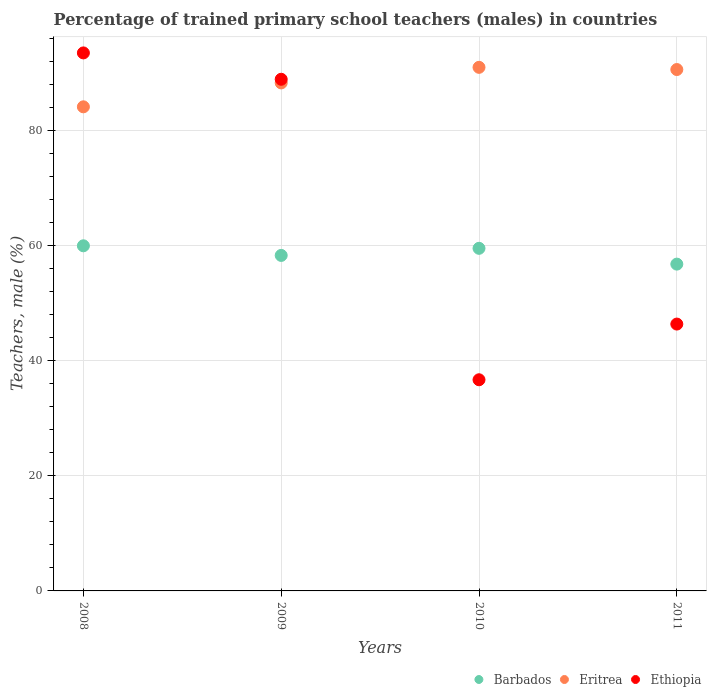How many different coloured dotlines are there?
Your answer should be compact. 3. What is the percentage of trained primary school teachers (males) in Ethiopia in 2008?
Offer a very short reply. 93.51. Across all years, what is the maximum percentage of trained primary school teachers (males) in Ethiopia?
Provide a succinct answer. 93.51. Across all years, what is the minimum percentage of trained primary school teachers (males) in Eritrea?
Your answer should be compact. 84.14. In which year was the percentage of trained primary school teachers (males) in Eritrea maximum?
Your answer should be very brief. 2010. In which year was the percentage of trained primary school teachers (males) in Eritrea minimum?
Provide a succinct answer. 2008. What is the total percentage of trained primary school teachers (males) in Barbados in the graph?
Ensure brevity in your answer.  234.65. What is the difference between the percentage of trained primary school teachers (males) in Ethiopia in 2010 and that in 2011?
Provide a short and direct response. -9.68. What is the difference between the percentage of trained primary school teachers (males) in Eritrea in 2008 and the percentage of trained primary school teachers (males) in Ethiopia in 2010?
Keep it short and to the point. 47.44. What is the average percentage of trained primary school teachers (males) in Eritrea per year?
Ensure brevity in your answer.  88.52. In the year 2010, what is the difference between the percentage of trained primary school teachers (males) in Barbados and percentage of trained primary school teachers (males) in Eritrea?
Provide a short and direct response. -31.46. What is the ratio of the percentage of trained primary school teachers (males) in Barbados in 2008 to that in 2009?
Your response must be concise. 1.03. Is the percentage of trained primary school teachers (males) in Ethiopia in 2008 less than that in 2009?
Your answer should be compact. No. What is the difference between the highest and the second highest percentage of trained primary school teachers (males) in Barbados?
Your answer should be very brief. 0.44. What is the difference between the highest and the lowest percentage of trained primary school teachers (males) in Eritrea?
Offer a terse response. 6.86. In how many years, is the percentage of trained primary school teachers (males) in Ethiopia greater than the average percentage of trained primary school teachers (males) in Ethiopia taken over all years?
Offer a very short reply. 2. Is it the case that in every year, the sum of the percentage of trained primary school teachers (males) in Eritrea and percentage of trained primary school teachers (males) in Ethiopia  is greater than the percentage of trained primary school teachers (males) in Barbados?
Your answer should be very brief. Yes. Is the percentage of trained primary school teachers (males) in Eritrea strictly greater than the percentage of trained primary school teachers (males) in Barbados over the years?
Ensure brevity in your answer.  Yes. How many dotlines are there?
Make the answer very short. 3. Are the values on the major ticks of Y-axis written in scientific E-notation?
Provide a short and direct response. No. Does the graph contain any zero values?
Give a very brief answer. No. How many legend labels are there?
Offer a very short reply. 3. How are the legend labels stacked?
Your answer should be very brief. Horizontal. What is the title of the graph?
Give a very brief answer. Percentage of trained primary school teachers (males) in countries. What is the label or title of the X-axis?
Keep it short and to the point. Years. What is the label or title of the Y-axis?
Ensure brevity in your answer.  Teachers, male (%). What is the Teachers, male (%) in Barbados in 2008?
Your answer should be very brief. 59.99. What is the Teachers, male (%) of Eritrea in 2008?
Provide a short and direct response. 84.14. What is the Teachers, male (%) in Ethiopia in 2008?
Offer a very short reply. 93.51. What is the Teachers, male (%) in Barbados in 2009?
Ensure brevity in your answer.  58.31. What is the Teachers, male (%) in Eritrea in 2009?
Offer a very short reply. 88.3. What is the Teachers, male (%) in Ethiopia in 2009?
Your response must be concise. 88.93. What is the Teachers, male (%) in Barbados in 2010?
Offer a terse response. 59.55. What is the Teachers, male (%) of Eritrea in 2010?
Your answer should be compact. 91. What is the Teachers, male (%) in Ethiopia in 2010?
Your response must be concise. 36.7. What is the Teachers, male (%) of Barbados in 2011?
Keep it short and to the point. 56.8. What is the Teachers, male (%) in Eritrea in 2011?
Your answer should be very brief. 90.62. What is the Teachers, male (%) of Ethiopia in 2011?
Keep it short and to the point. 46.38. Across all years, what is the maximum Teachers, male (%) of Barbados?
Provide a short and direct response. 59.99. Across all years, what is the maximum Teachers, male (%) in Eritrea?
Offer a very short reply. 91. Across all years, what is the maximum Teachers, male (%) of Ethiopia?
Give a very brief answer. 93.51. Across all years, what is the minimum Teachers, male (%) of Barbados?
Your response must be concise. 56.8. Across all years, what is the minimum Teachers, male (%) of Eritrea?
Offer a very short reply. 84.14. Across all years, what is the minimum Teachers, male (%) in Ethiopia?
Keep it short and to the point. 36.7. What is the total Teachers, male (%) in Barbados in the graph?
Your answer should be very brief. 234.65. What is the total Teachers, male (%) in Eritrea in the graph?
Offer a very short reply. 354.06. What is the total Teachers, male (%) of Ethiopia in the graph?
Ensure brevity in your answer.  265.52. What is the difference between the Teachers, male (%) in Barbados in 2008 and that in 2009?
Offer a very short reply. 1.67. What is the difference between the Teachers, male (%) in Eritrea in 2008 and that in 2009?
Offer a terse response. -4.15. What is the difference between the Teachers, male (%) in Ethiopia in 2008 and that in 2009?
Provide a short and direct response. 4.58. What is the difference between the Teachers, male (%) of Barbados in 2008 and that in 2010?
Keep it short and to the point. 0.44. What is the difference between the Teachers, male (%) of Eritrea in 2008 and that in 2010?
Provide a short and direct response. -6.86. What is the difference between the Teachers, male (%) of Ethiopia in 2008 and that in 2010?
Your answer should be very brief. 56.81. What is the difference between the Teachers, male (%) of Barbados in 2008 and that in 2011?
Make the answer very short. 3.18. What is the difference between the Teachers, male (%) of Eritrea in 2008 and that in 2011?
Your response must be concise. -6.48. What is the difference between the Teachers, male (%) in Ethiopia in 2008 and that in 2011?
Provide a succinct answer. 47.13. What is the difference between the Teachers, male (%) of Barbados in 2009 and that in 2010?
Offer a terse response. -1.23. What is the difference between the Teachers, male (%) of Eritrea in 2009 and that in 2010?
Keep it short and to the point. -2.71. What is the difference between the Teachers, male (%) of Ethiopia in 2009 and that in 2010?
Your answer should be very brief. 52.23. What is the difference between the Teachers, male (%) in Barbados in 2009 and that in 2011?
Offer a very short reply. 1.51. What is the difference between the Teachers, male (%) in Eritrea in 2009 and that in 2011?
Keep it short and to the point. -2.33. What is the difference between the Teachers, male (%) of Ethiopia in 2009 and that in 2011?
Offer a terse response. 42.55. What is the difference between the Teachers, male (%) in Barbados in 2010 and that in 2011?
Your answer should be very brief. 2.75. What is the difference between the Teachers, male (%) in Eritrea in 2010 and that in 2011?
Offer a terse response. 0.38. What is the difference between the Teachers, male (%) in Ethiopia in 2010 and that in 2011?
Make the answer very short. -9.68. What is the difference between the Teachers, male (%) in Barbados in 2008 and the Teachers, male (%) in Eritrea in 2009?
Your response must be concise. -28.31. What is the difference between the Teachers, male (%) of Barbados in 2008 and the Teachers, male (%) of Ethiopia in 2009?
Your answer should be compact. -28.94. What is the difference between the Teachers, male (%) of Eritrea in 2008 and the Teachers, male (%) of Ethiopia in 2009?
Offer a terse response. -4.79. What is the difference between the Teachers, male (%) in Barbados in 2008 and the Teachers, male (%) in Eritrea in 2010?
Provide a short and direct response. -31.02. What is the difference between the Teachers, male (%) in Barbados in 2008 and the Teachers, male (%) in Ethiopia in 2010?
Offer a terse response. 23.28. What is the difference between the Teachers, male (%) of Eritrea in 2008 and the Teachers, male (%) of Ethiopia in 2010?
Offer a terse response. 47.44. What is the difference between the Teachers, male (%) in Barbados in 2008 and the Teachers, male (%) in Eritrea in 2011?
Keep it short and to the point. -30.64. What is the difference between the Teachers, male (%) of Barbados in 2008 and the Teachers, male (%) of Ethiopia in 2011?
Provide a short and direct response. 13.6. What is the difference between the Teachers, male (%) of Eritrea in 2008 and the Teachers, male (%) of Ethiopia in 2011?
Ensure brevity in your answer.  37.76. What is the difference between the Teachers, male (%) of Barbados in 2009 and the Teachers, male (%) of Eritrea in 2010?
Provide a short and direct response. -32.69. What is the difference between the Teachers, male (%) in Barbados in 2009 and the Teachers, male (%) in Ethiopia in 2010?
Your response must be concise. 21.61. What is the difference between the Teachers, male (%) in Eritrea in 2009 and the Teachers, male (%) in Ethiopia in 2010?
Your answer should be compact. 51.59. What is the difference between the Teachers, male (%) in Barbados in 2009 and the Teachers, male (%) in Eritrea in 2011?
Give a very brief answer. -32.31. What is the difference between the Teachers, male (%) of Barbados in 2009 and the Teachers, male (%) of Ethiopia in 2011?
Offer a terse response. 11.93. What is the difference between the Teachers, male (%) in Eritrea in 2009 and the Teachers, male (%) in Ethiopia in 2011?
Provide a succinct answer. 41.91. What is the difference between the Teachers, male (%) of Barbados in 2010 and the Teachers, male (%) of Eritrea in 2011?
Give a very brief answer. -31.07. What is the difference between the Teachers, male (%) of Barbados in 2010 and the Teachers, male (%) of Ethiopia in 2011?
Provide a short and direct response. 13.16. What is the difference between the Teachers, male (%) in Eritrea in 2010 and the Teachers, male (%) in Ethiopia in 2011?
Give a very brief answer. 44.62. What is the average Teachers, male (%) of Barbados per year?
Provide a succinct answer. 58.66. What is the average Teachers, male (%) in Eritrea per year?
Give a very brief answer. 88.52. What is the average Teachers, male (%) of Ethiopia per year?
Provide a short and direct response. 66.38. In the year 2008, what is the difference between the Teachers, male (%) in Barbados and Teachers, male (%) in Eritrea?
Keep it short and to the point. -24.16. In the year 2008, what is the difference between the Teachers, male (%) of Barbados and Teachers, male (%) of Ethiopia?
Provide a succinct answer. -33.52. In the year 2008, what is the difference between the Teachers, male (%) of Eritrea and Teachers, male (%) of Ethiopia?
Make the answer very short. -9.37. In the year 2009, what is the difference between the Teachers, male (%) in Barbados and Teachers, male (%) in Eritrea?
Your response must be concise. -29.98. In the year 2009, what is the difference between the Teachers, male (%) in Barbados and Teachers, male (%) in Ethiopia?
Offer a very short reply. -30.62. In the year 2009, what is the difference between the Teachers, male (%) in Eritrea and Teachers, male (%) in Ethiopia?
Provide a short and direct response. -0.63. In the year 2010, what is the difference between the Teachers, male (%) in Barbados and Teachers, male (%) in Eritrea?
Provide a succinct answer. -31.46. In the year 2010, what is the difference between the Teachers, male (%) in Barbados and Teachers, male (%) in Ethiopia?
Give a very brief answer. 22.85. In the year 2010, what is the difference between the Teachers, male (%) of Eritrea and Teachers, male (%) of Ethiopia?
Ensure brevity in your answer.  54.3. In the year 2011, what is the difference between the Teachers, male (%) of Barbados and Teachers, male (%) of Eritrea?
Offer a terse response. -33.82. In the year 2011, what is the difference between the Teachers, male (%) of Barbados and Teachers, male (%) of Ethiopia?
Offer a very short reply. 10.42. In the year 2011, what is the difference between the Teachers, male (%) in Eritrea and Teachers, male (%) in Ethiopia?
Give a very brief answer. 44.24. What is the ratio of the Teachers, male (%) in Barbados in 2008 to that in 2009?
Give a very brief answer. 1.03. What is the ratio of the Teachers, male (%) in Eritrea in 2008 to that in 2009?
Ensure brevity in your answer.  0.95. What is the ratio of the Teachers, male (%) in Ethiopia in 2008 to that in 2009?
Offer a very short reply. 1.05. What is the ratio of the Teachers, male (%) in Barbados in 2008 to that in 2010?
Your response must be concise. 1.01. What is the ratio of the Teachers, male (%) in Eritrea in 2008 to that in 2010?
Ensure brevity in your answer.  0.92. What is the ratio of the Teachers, male (%) in Ethiopia in 2008 to that in 2010?
Ensure brevity in your answer.  2.55. What is the ratio of the Teachers, male (%) in Barbados in 2008 to that in 2011?
Provide a short and direct response. 1.06. What is the ratio of the Teachers, male (%) of Eritrea in 2008 to that in 2011?
Provide a short and direct response. 0.93. What is the ratio of the Teachers, male (%) of Ethiopia in 2008 to that in 2011?
Your answer should be very brief. 2.02. What is the ratio of the Teachers, male (%) of Barbados in 2009 to that in 2010?
Give a very brief answer. 0.98. What is the ratio of the Teachers, male (%) in Eritrea in 2009 to that in 2010?
Ensure brevity in your answer.  0.97. What is the ratio of the Teachers, male (%) in Ethiopia in 2009 to that in 2010?
Your answer should be very brief. 2.42. What is the ratio of the Teachers, male (%) in Barbados in 2009 to that in 2011?
Give a very brief answer. 1.03. What is the ratio of the Teachers, male (%) in Eritrea in 2009 to that in 2011?
Make the answer very short. 0.97. What is the ratio of the Teachers, male (%) in Ethiopia in 2009 to that in 2011?
Give a very brief answer. 1.92. What is the ratio of the Teachers, male (%) in Barbados in 2010 to that in 2011?
Give a very brief answer. 1.05. What is the ratio of the Teachers, male (%) in Eritrea in 2010 to that in 2011?
Offer a very short reply. 1. What is the ratio of the Teachers, male (%) of Ethiopia in 2010 to that in 2011?
Offer a terse response. 0.79. What is the difference between the highest and the second highest Teachers, male (%) of Barbados?
Offer a very short reply. 0.44. What is the difference between the highest and the second highest Teachers, male (%) in Eritrea?
Provide a succinct answer. 0.38. What is the difference between the highest and the second highest Teachers, male (%) of Ethiopia?
Your answer should be compact. 4.58. What is the difference between the highest and the lowest Teachers, male (%) of Barbados?
Ensure brevity in your answer.  3.18. What is the difference between the highest and the lowest Teachers, male (%) in Eritrea?
Provide a short and direct response. 6.86. What is the difference between the highest and the lowest Teachers, male (%) in Ethiopia?
Offer a terse response. 56.81. 